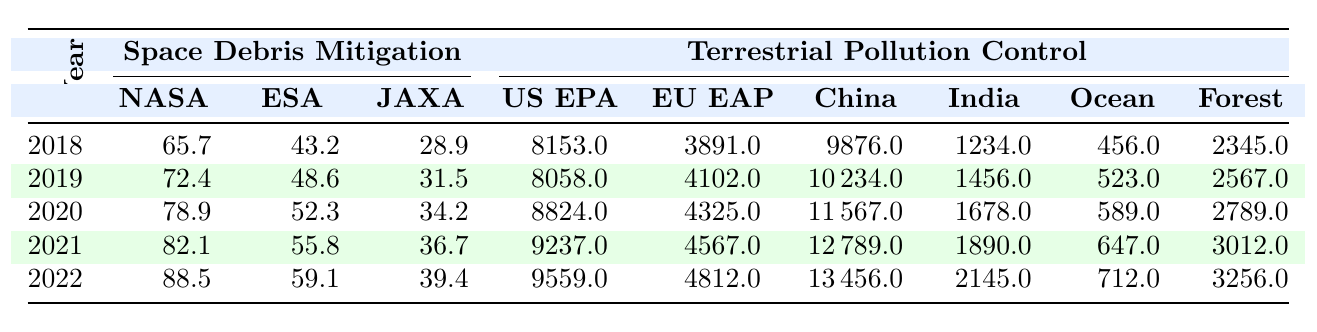What was the NASA budget for space debris mitigation in 2020? Referring to the 2020 row in the table, the NASA budget is listed as 78.9 million dollars.
Answer: 78.9 million Which agency had the highest budget for terrestrial pollution control in 2021? In 2021, the budgets for the agencies are: US EPA (9237), EU EAP (4567), China (12789), India (1890), Ocean (647), and Forest (3012). The highest budget is from China at 12789 million dollars.
Answer: China What was the total budget allocated for space debris mitigation across NASA, ESA, and JAXA in 2019? In 2019, the total budget is calculated as follows: NASA (72.4) + ESA (48.6) + JAXA (31.5) = 72.4 + 48.6 + 31.5 = 152.5 million dollars.
Answer: 152.5 million Did the US EPA budget for pollution control increase every year from 2018 to 2022? The US EPA budgets are: 8153 (2018), 8058 (2019), 8824 (2020), 9237 (2021), and 9559 (2022). The budget decreased in 2019 compared to 2018, meaning it did not increase every year.
Answer: No What was the average budget for pollution control in India from 2018 to 2022? To find the average, sum the budgets for each year: (1234 + 1456 + 1678 + 1890 + 2145) = 10603, then divide by the number of years, 5: 10603 / 5 = 2120.6 million dollars.
Answer: 2120.6 million Which year had the highest combined budget for ESA and JAXA space debris mitigation? The combined budgets are: 2018 (43.2 + 28.9 = 72.1), 2019 (48.6 + 31.5 = 80.1), 2020 (52.3 + 34.2 = 86.5), 2021 (55.8 + 36.7 = 92.5), and 2022 (59.1 + 39.4 = 98.5). The highest combined budget is in 2022 with 98.5 million dollars.
Answer: 2022 How much more did the US EPA spend on pollution control compared to NASA’s space debris budget in 2022? The US EPA budget in 2022 is 9559 million, while NASA's budget is 88.5 million. The difference is 9559 - 88.5 = 9470.5 million dollars.
Answer: 9470.5 million List the years when the ESA budget for space debris mitigation exceeded the JAXA budget. The ESA budgets are: 43.2 (2018), 48.6 (2019), 52.3 (2020), 55.8 (2021), and 59.1 (2022). The JAXA budgets are: 28.9 (2018), 31.5 (2019), 34.2 (2020), 36.7 (2021), and 39.4 (2022). ESA exceeded JAXA in all years (2018 to 2022).
Answer: 2018, 2019, 2020, 2021, 2022 What percentage of the total environmental action budget (US EPA, EU EAP, China, India, Ocean, Forest) was allocated to the US EPA in 2020? The total budget for 2020 is: 8824 (US EPA) + 4325 (EU EAP) + 11567 (China) + 1678 (India) + 589 (Ocean) + 2789 (Forest) = 28472 million. The percentage for US EPA is (8824 / 28472) * 100 = 31.0%.
Answer: 31.0% 